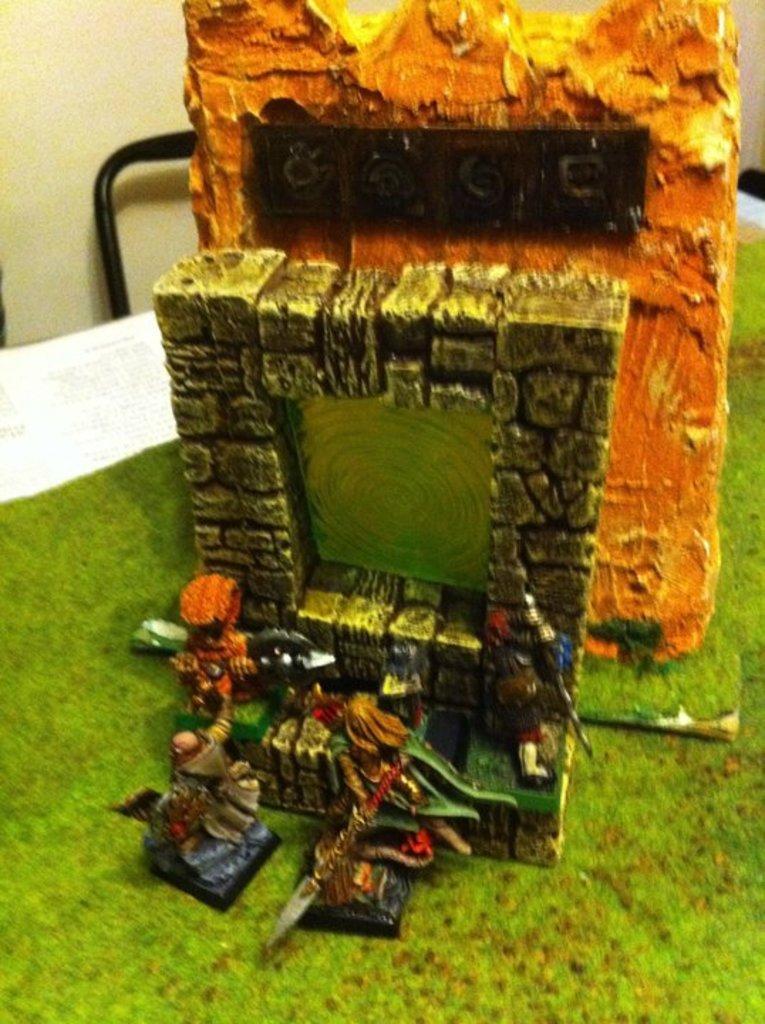Can you describe this image briefly? In this image I can see the miniature of colorful objects. I can see few toy people and these are on the green and white color surface. Background is in cream color. 